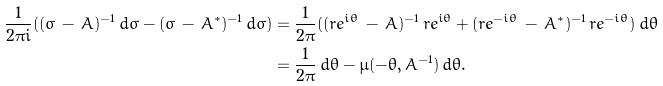Convert formula to latex. <formula><loc_0><loc_0><loc_500><loc_500>\frac { 1 } { 2 \pi i } ( ( \sigma \, - \, A ) ^ { - 1 } \, d \sigma - ( \bar { \sigma } \, - \, A ^ { * } ) ^ { - 1 } \, d \bar { \sigma } ) & = \frac { 1 } { 2 \pi } ( ( r e ^ { i \theta } \, - \, A ) ^ { - 1 } \, r e ^ { i \theta } + ( r e ^ { - i \theta } \, - \, A ^ { * } ) ^ { - 1 } \, r e ^ { - i \theta } ) \, d \theta \\ & = \frac { 1 } { 2 \pi } \, d \theta - \mu ( - \theta , A ^ { - 1 } ) \, d \theta .</formula> 